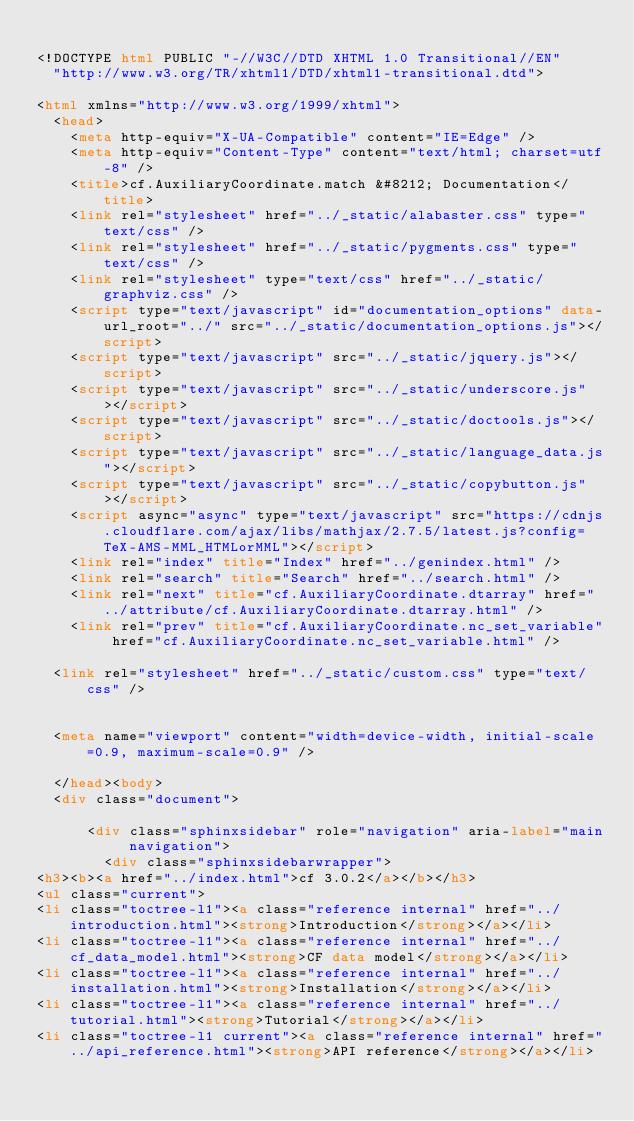Convert code to text. <code><loc_0><loc_0><loc_500><loc_500><_HTML_>
<!DOCTYPE html PUBLIC "-//W3C//DTD XHTML 1.0 Transitional//EN"
  "http://www.w3.org/TR/xhtml1/DTD/xhtml1-transitional.dtd">

<html xmlns="http://www.w3.org/1999/xhtml">
  <head>
    <meta http-equiv="X-UA-Compatible" content="IE=Edge" />
    <meta http-equiv="Content-Type" content="text/html; charset=utf-8" />
    <title>cf.AuxiliaryCoordinate.match &#8212; Documentation</title>
    <link rel="stylesheet" href="../_static/alabaster.css" type="text/css" />
    <link rel="stylesheet" href="../_static/pygments.css" type="text/css" />
    <link rel="stylesheet" type="text/css" href="../_static/graphviz.css" />
    <script type="text/javascript" id="documentation_options" data-url_root="../" src="../_static/documentation_options.js"></script>
    <script type="text/javascript" src="../_static/jquery.js"></script>
    <script type="text/javascript" src="../_static/underscore.js"></script>
    <script type="text/javascript" src="../_static/doctools.js"></script>
    <script type="text/javascript" src="../_static/language_data.js"></script>
    <script type="text/javascript" src="../_static/copybutton.js"></script>
    <script async="async" type="text/javascript" src="https://cdnjs.cloudflare.com/ajax/libs/mathjax/2.7.5/latest.js?config=TeX-AMS-MML_HTMLorMML"></script>
    <link rel="index" title="Index" href="../genindex.html" />
    <link rel="search" title="Search" href="../search.html" />
    <link rel="next" title="cf.AuxiliaryCoordinate.dtarray" href="../attribute/cf.AuxiliaryCoordinate.dtarray.html" />
    <link rel="prev" title="cf.AuxiliaryCoordinate.nc_set_variable" href="cf.AuxiliaryCoordinate.nc_set_variable.html" />
   
  <link rel="stylesheet" href="../_static/custom.css" type="text/css" />
  
  
  <meta name="viewport" content="width=device-width, initial-scale=0.9, maximum-scale=0.9" />

  </head><body>
  <div class="document">
    
      <div class="sphinxsidebar" role="navigation" aria-label="main navigation">
        <div class="sphinxsidebarwrapper">
<h3><b><a href="../index.html">cf 3.0.2</a></b></h3>
<ul class="current">
<li class="toctree-l1"><a class="reference internal" href="../introduction.html"><strong>Introduction</strong></a></li>
<li class="toctree-l1"><a class="reference internal" href="../cf_data_model.html"><strong>CF data model</strong></a></li>
<li class="toctree-l1"><a class="reference internal" href="../installation.html"><strong>Installation</strong></a></li>
<li class="toctree-l1"><a class="reference internal" href="../tutorial.html"><strong>Tutorial</strong></a></li>
<li class="toctree-l1 current"><a class="reference internal" href="../api_reference.html"><strong>API reference</strong></a></li></code> 